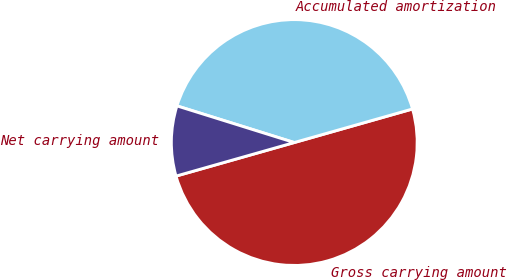Convert chart to OTSL. <chart><loc_0><loc_0><loc_500><loc_500><pie_chart><fcel>Gross carrying amount<fcel>Accumulated amortization<fcel>Net carrying amount<nl><fcel>50.0%<fcel>40.78%<fcel>9.22%<nl></chart> 